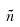Convert formula to latex. <formula><loc_0><loc_0><loc_500><loc_500>\tilde { n }</formula> 